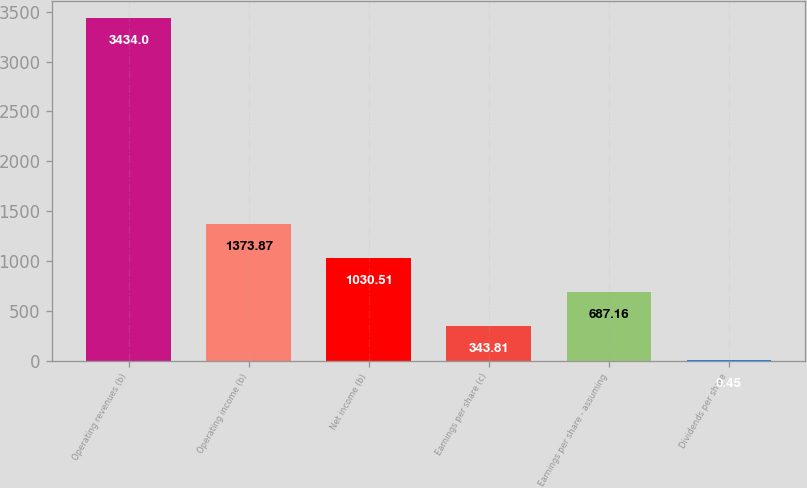Convert chart to OTSL. <chart><loc_0><loc_0><loc_500><loc_500><bar_chart><fcel>Operating revenues (b)<fcel>Operating income (b)<fcel>Net income (b)<fcel>Earnings per share (c)<fcel>Earnings per share - assuming<fcel>Dividends per share<nl><fcel>3434<fcel>1373.87<fcel>1030.51<fcel>343.81<fcel>687.16<fcel>0.45<nl></chart> 